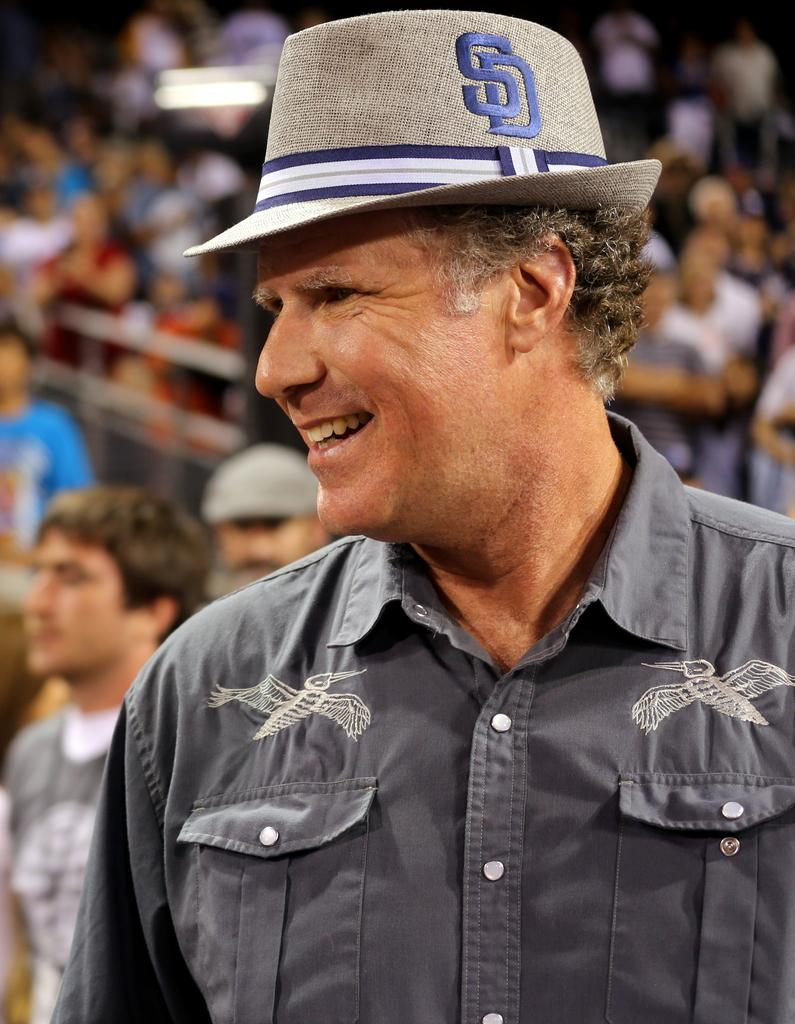Who is the main subject in the image? There is a man in the image. What is the man wearing on his head? The man is wearing a hat. In which direction is the man turning? The man is turning towards his left side. What is the man's facial expression? The man is smiling. How many people are visible behind the man? There is a huge crowd behind the man. What verse is being recited by the man in the image? There is no indication in the image that the man is reciting a verse. 